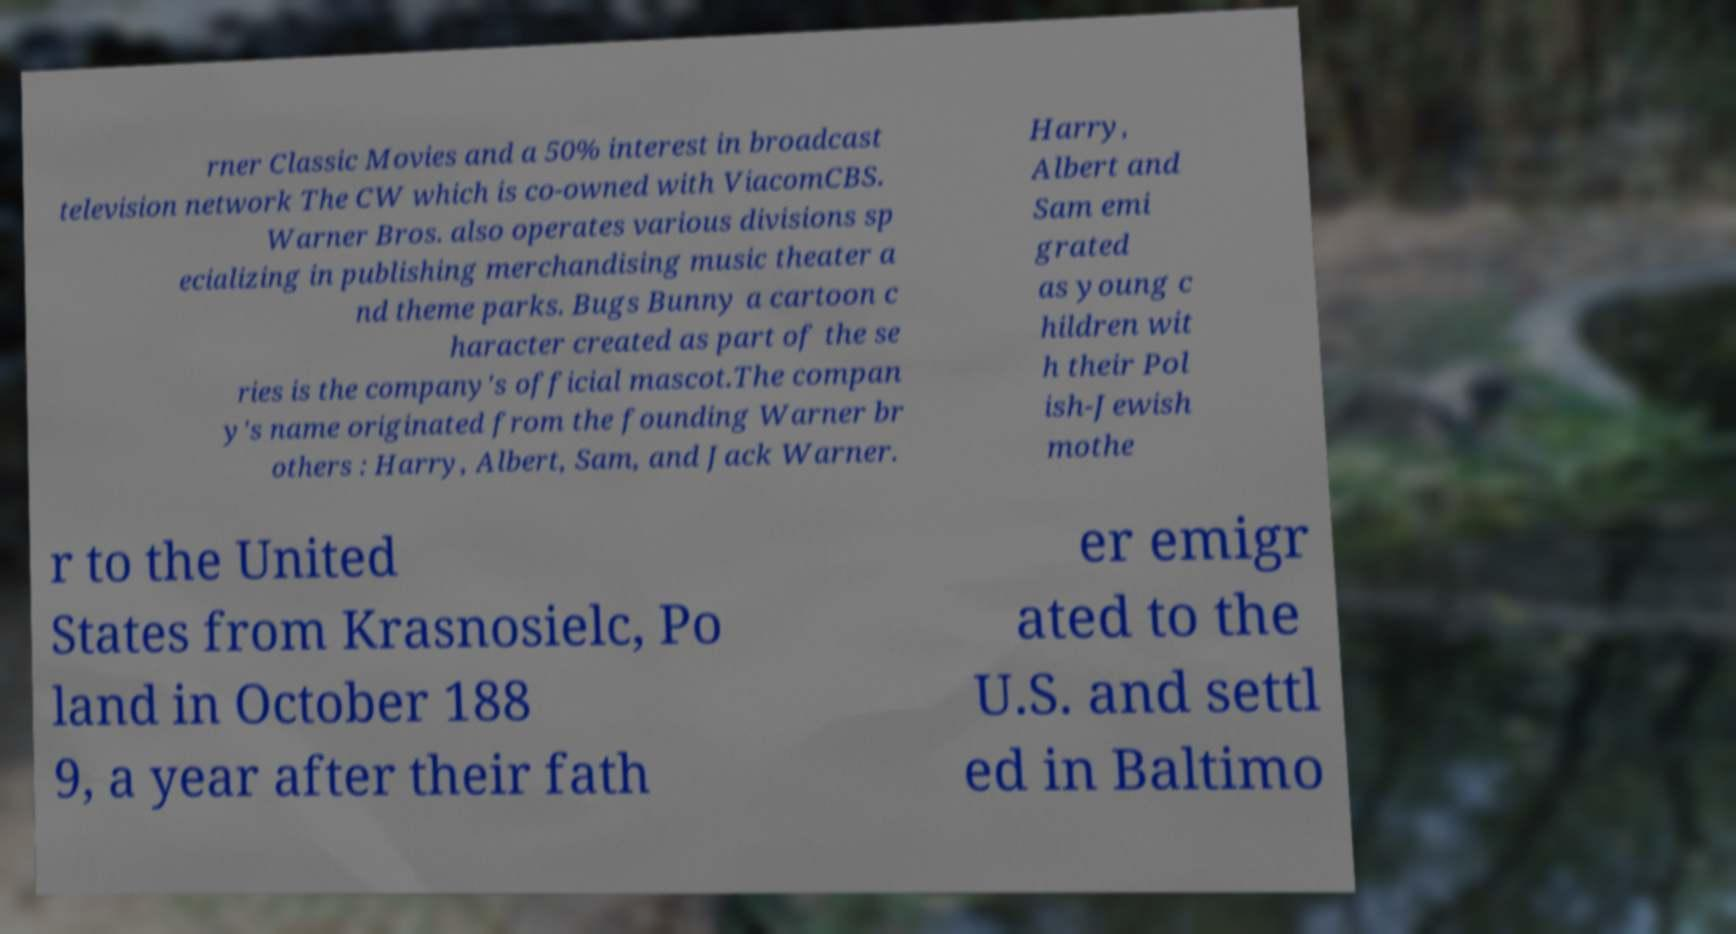Can you read and provide the text displayed in the image?This photo seems to have some interesting text. Can you extract and type it out for me? rner Classic Movies and a 50% interest in broadcast television network The CW which is co-owned with ViacomCBS. Warner Bros. also operates various divisions sp ecializing in publishing merchandising music theater a nd theme parks. Bugs Bunny a cartoon c haracter created as part of the se ries is the company's official mascot.The compan y's name originated from the founding Warner br others : Harry, Albert, Sam, and Jack Warner. Harry, Albert and Sam emi grated as young c hildren wit h their Pol ish-Jewish mothe r to the United States from Krasnosielc, Po land in October 188 9, a year after their fath er emigr ated to the U.S. and settl ed in Baltimo 